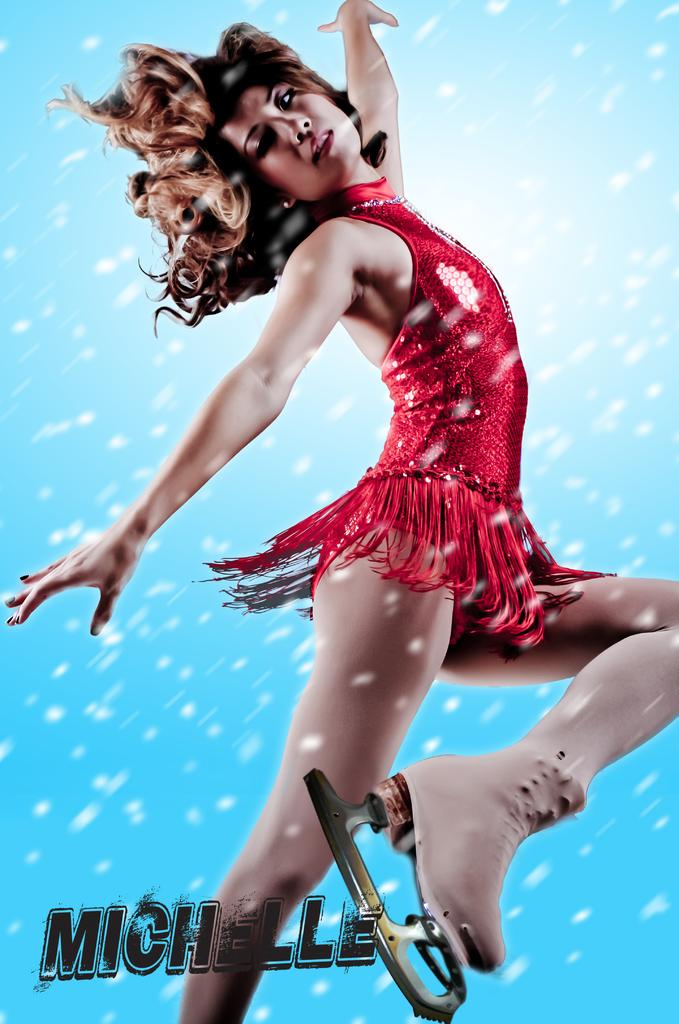Who is the main subject in the image? There is a woman in the image. What is the woman wearing? The woman is wearing a red dress. What color is the background of the image? The background of the image is blue. What type of lunch is the woman eating in the image? There is no lunch present in the image; it only features a woman wearing a red dress against a blue background. 